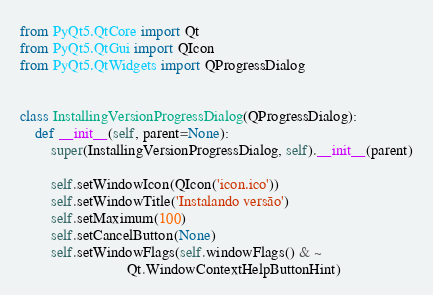<code> <loc_0><loc_0><loc_500><loc_500><_Python_>from PyQt5.QtCore import Qt
from PyQt5.QtGui import QIcon
from PyQt5.QtWidgets import QProgressDialog


class InstallingVersionProgressDialog(QProgressDialog):
    def __init__(self, parent=None):
        super(InstallingVersionProgressDialog, self).__init__(parent)

        self.setWindowIcon(QIcon('icon.ico'))
        self.setWindowTitle('Instalando versão')
        self.setMaximum(100)
        self.setCancelButton(None)
        self.setWindowFlags(self.windowFlags() & ~
                            Qt.WindowContextHelpButtonHint)
</code> 